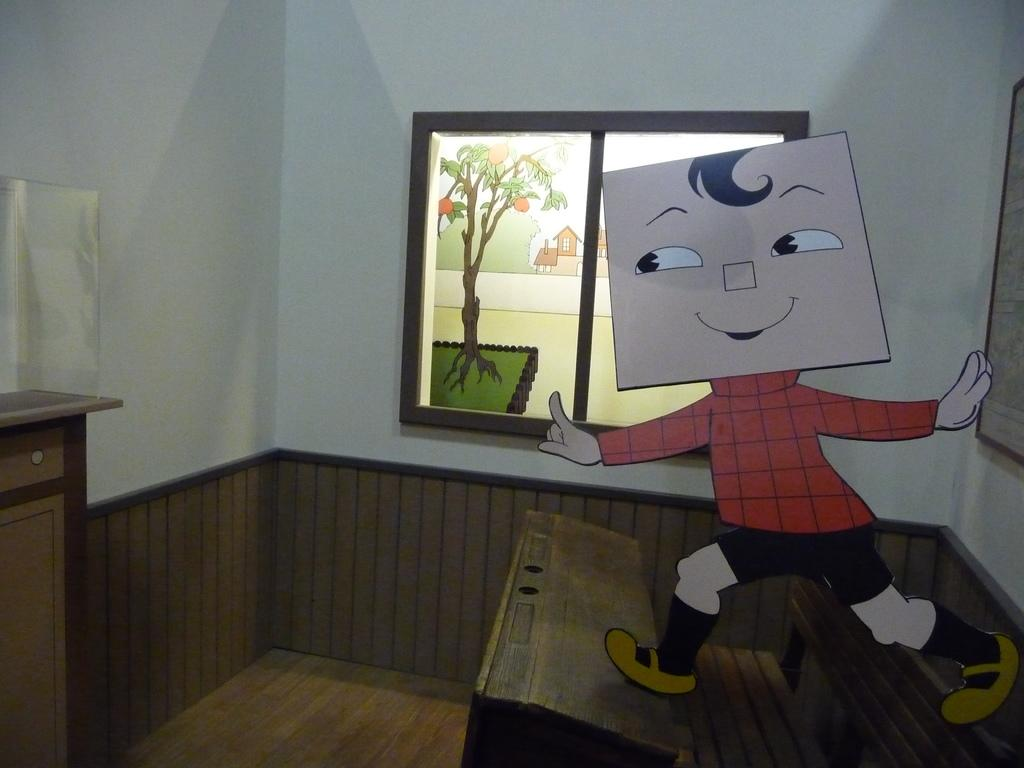What is located in the center of the image? There is a window in the center of the image. What can be seen on the right side of the image? There is a portrait and a cartoon character on the right side of the image. What type of lettuce is being used as a frame for the cartoon character in the image? There is no lettuce present in the image, nor is it being used as a frame for the cartoon character. 